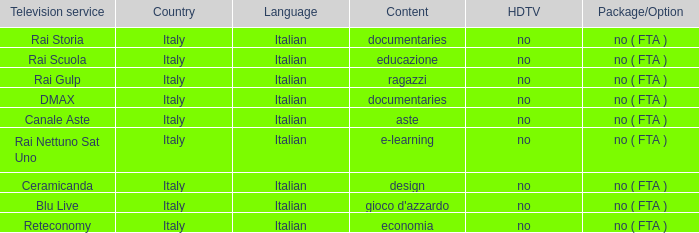What is the Language when the Reteconomy is the television service? Italian. 